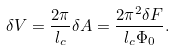Convert formula to latex. <formula><loc_0><loc_0><loc_500><loc_500>\delta V = \frac { 2 \pi } { l _ { c } } \delta A = \frac { 2 \pi ^ { 2 } \delta F } { l _ { c } \Phi _ { 0 } } .</formula> 